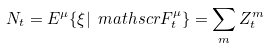Convert formula to latex. <formula><loc_0><loc_0><loc_500><loc_500>N _ { t } = E ^ { \mu } \{ \xi | \ m a t h s c r { F } _ { t } ^ { \mu } \} = \sum _ { m } Z _ { t } ^ { m }</formula> 